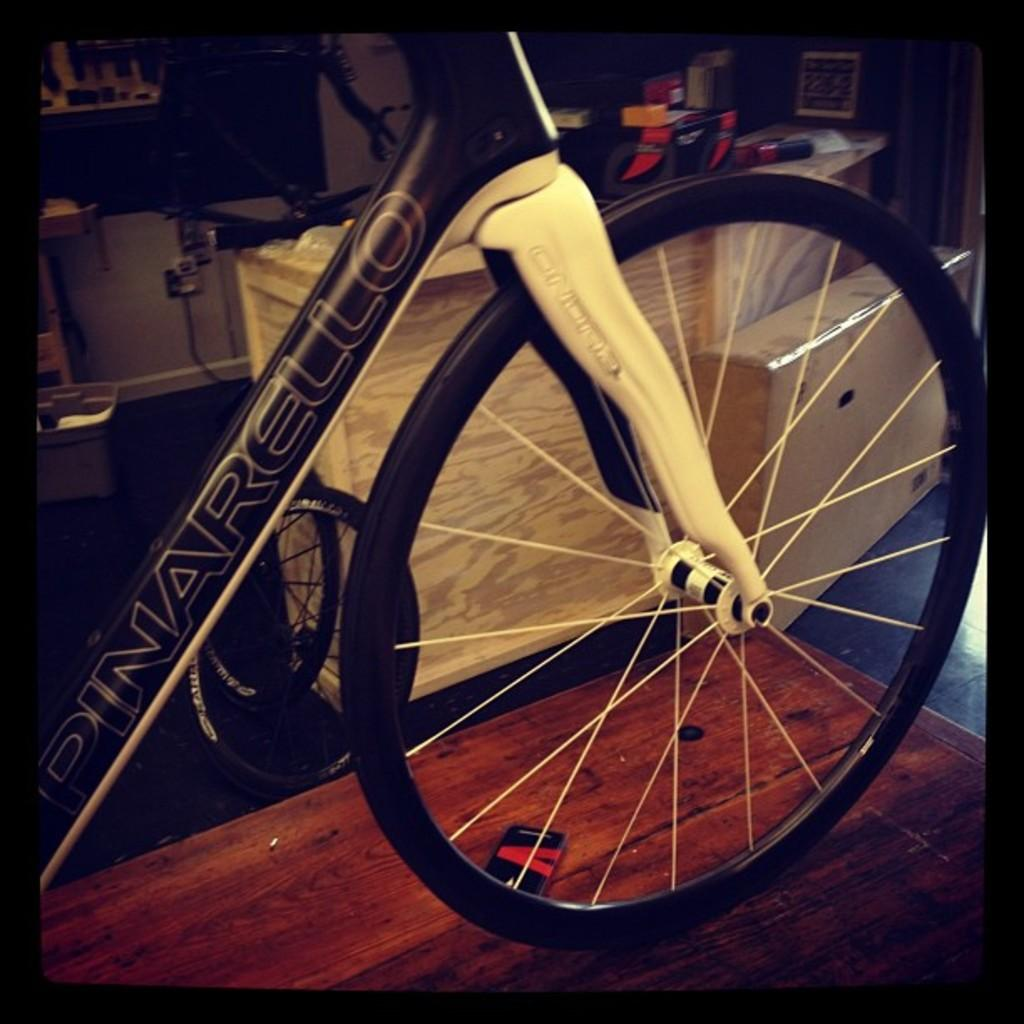What is placed on the table in the image? There is a bicycle on a table in the image. Can you describe the objects in the background of the image? Unfortunately, the provided facts do not give any information about the objects in the background. Is the throne made of gold in the image? There is no throne present in the image. 